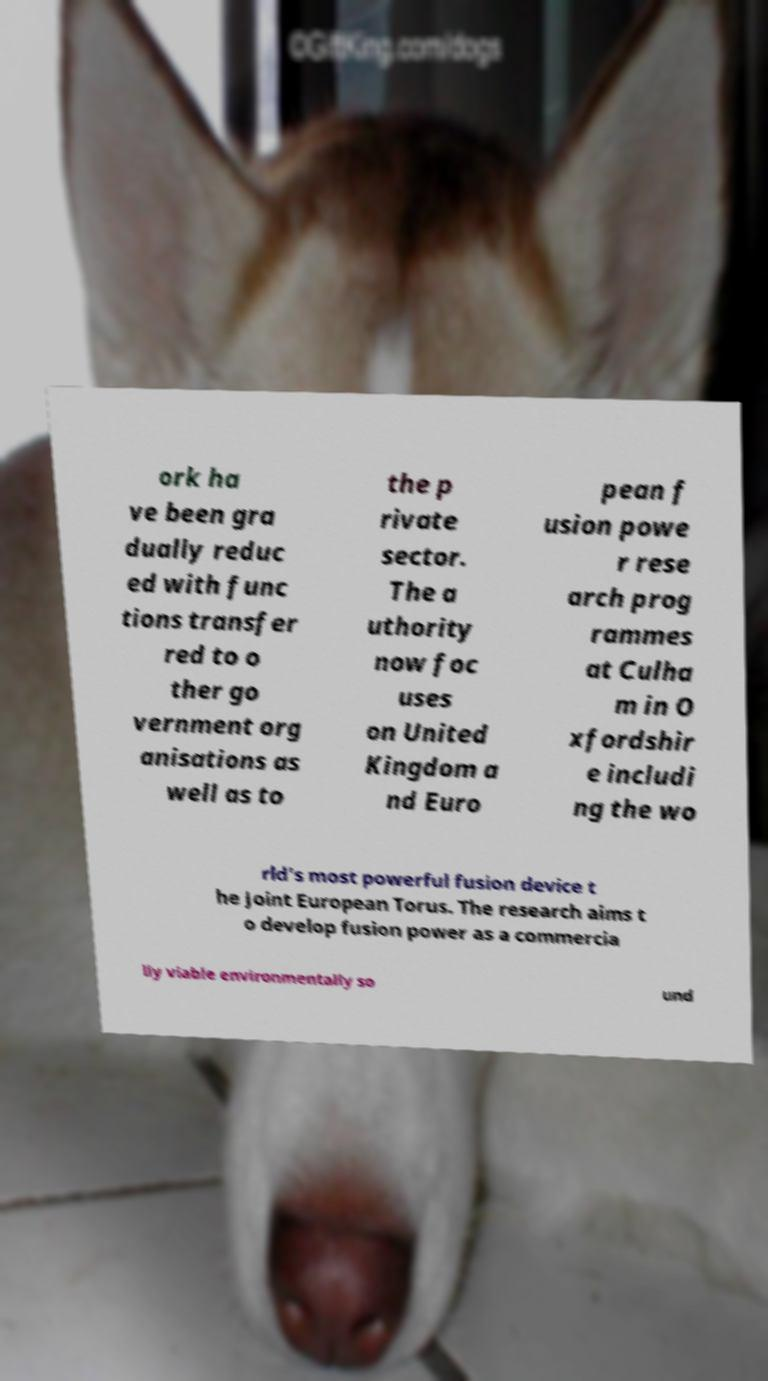Please identify and transcribe the text found in this image. ork ha ve been gra dually reduc ed with func tions transfer red to o ther go vernment org anisations as well as to the p rivate sector. The a uthority now foc uses on United Kingdom a nd Euro pean f usion powe r rese arch prog rammes at Culha m in O xfordshir e includi ng the wo rld's most powerful fusion device t he Joint European Torus. The research aims t o develop fusion power as a commercia lly viable environmentally so und 